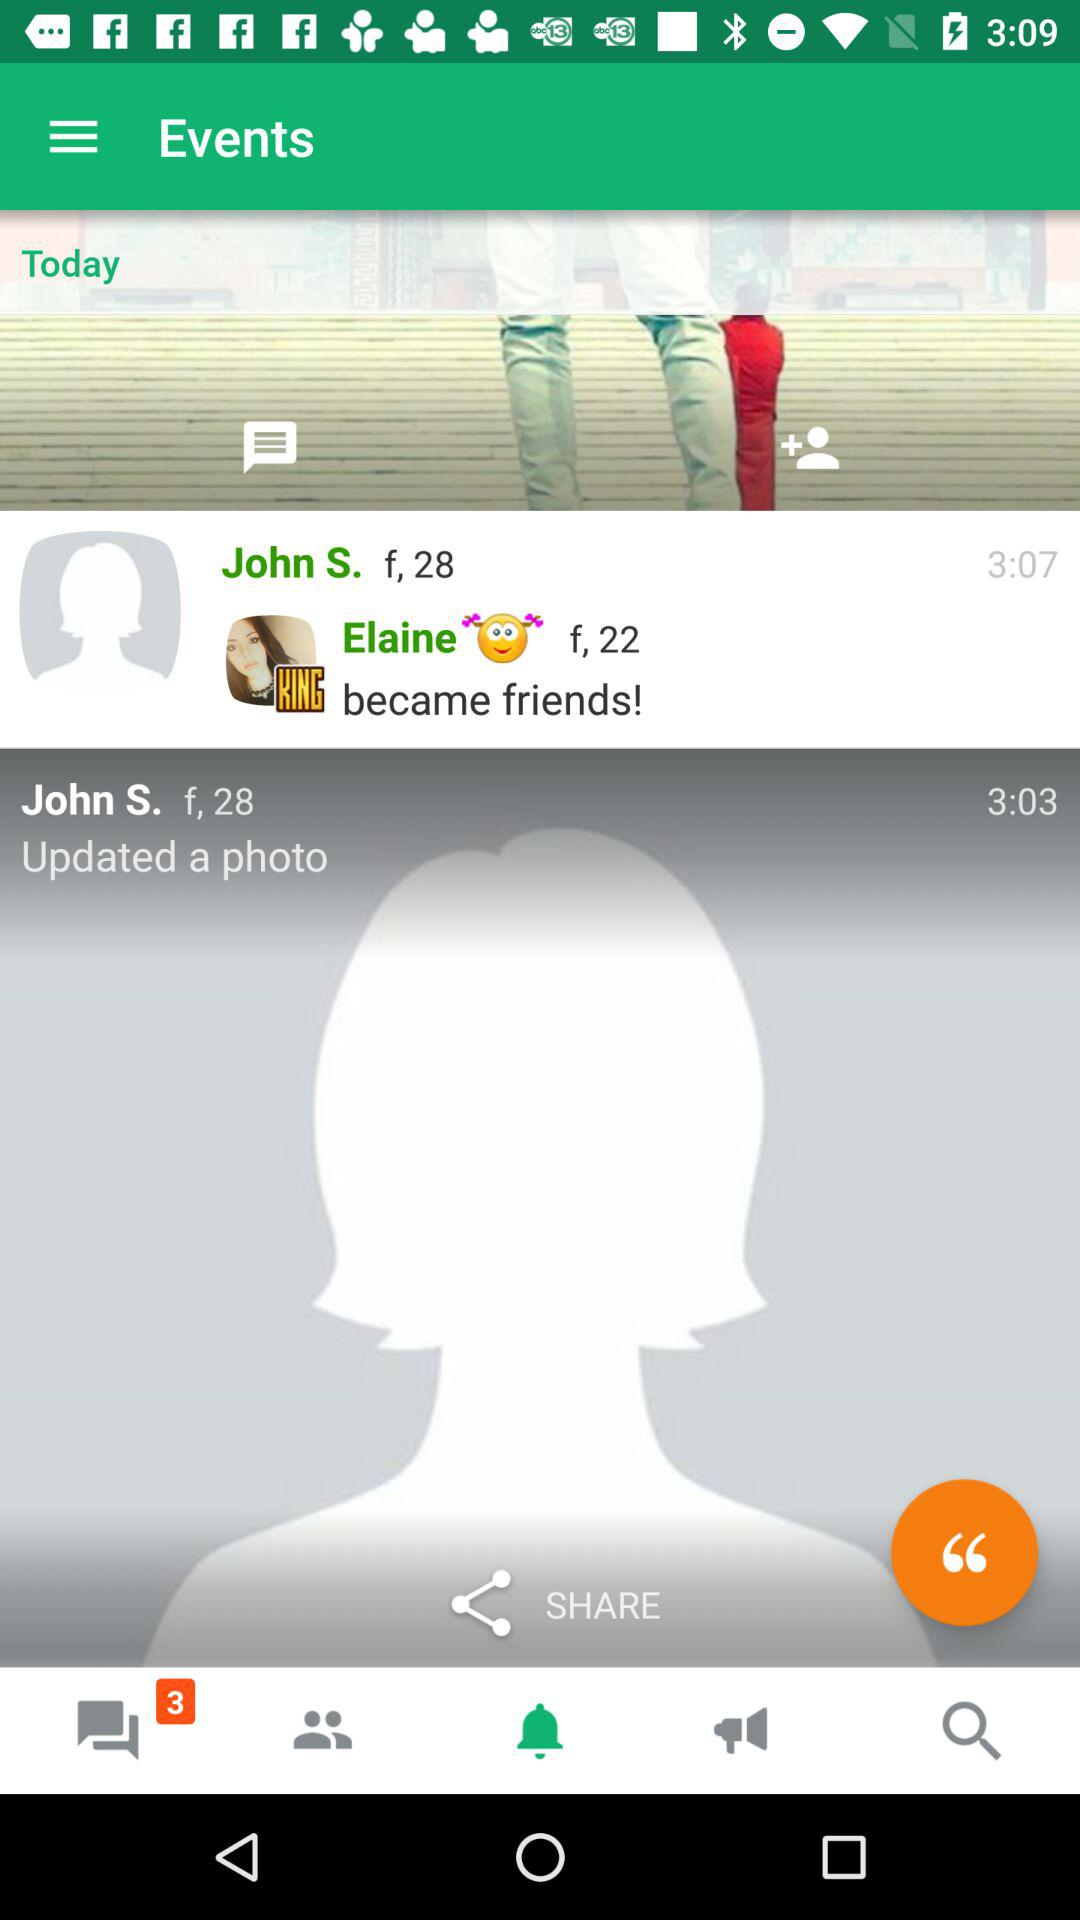At what time did John S. update a photo? John S. updated the photo at 3:03. 